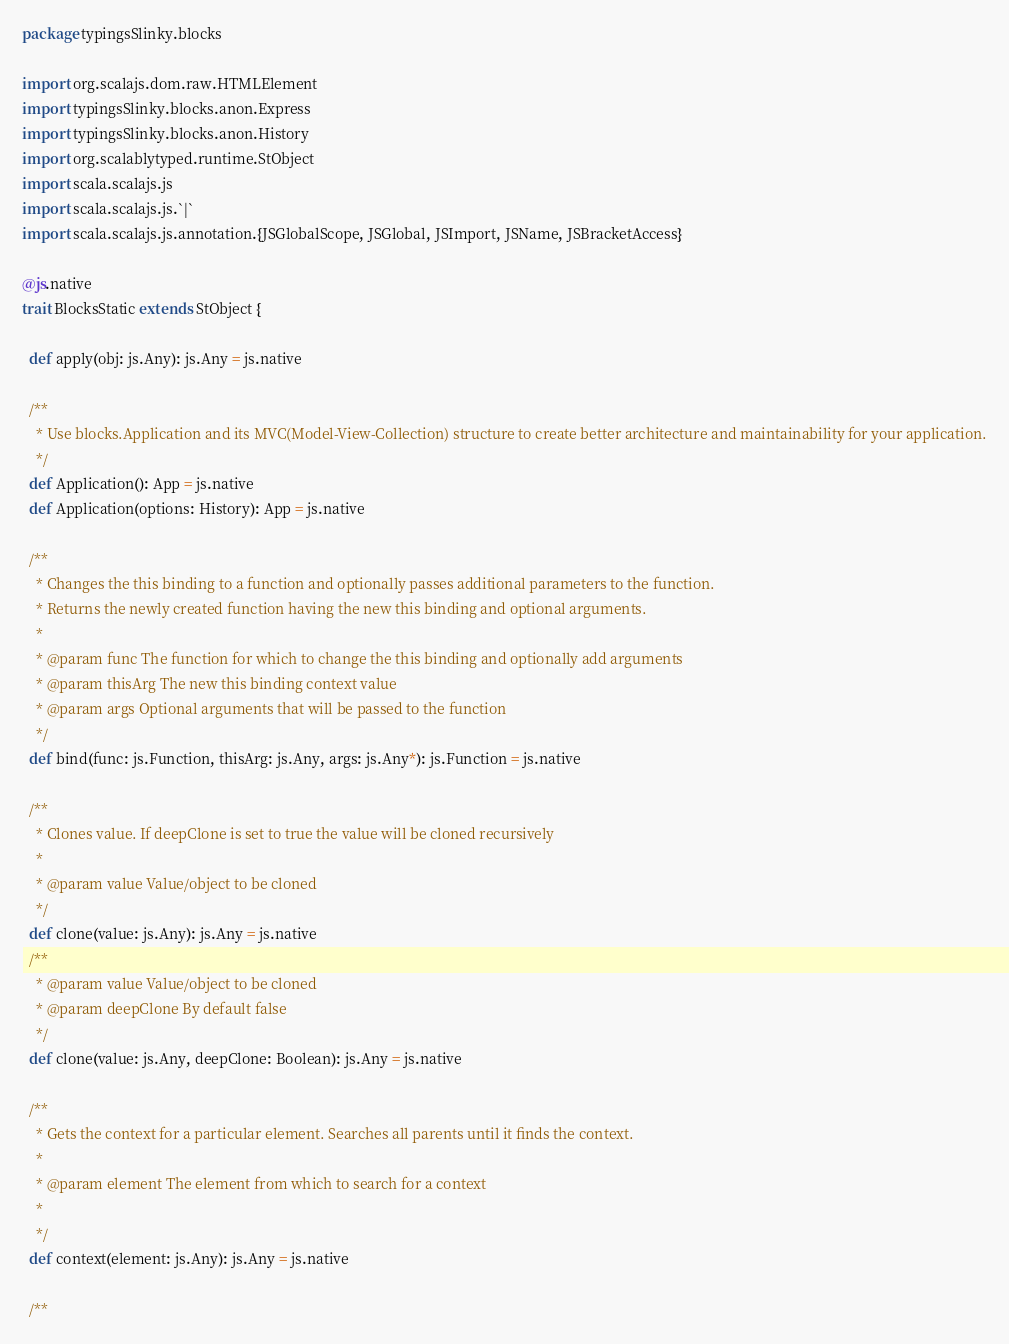<code> <loc_0><loc_0><loc_500><loc_500><_Scala_>package typingsSlinky.blocks

import org.scalajs.dom.raw.HTMLElement
import typingsSlinky.blocks.anon.Express
import typingsSlinky.blocks.anon.History
import org.scalablytyped.runtime.StObject
import scala.scalajs.js
import scala.scalajs.js.`|`
import scala.scalajs.js.annotation.{JSGlobalScope, JSGlobal, JSImport, JSName, JSBracketAccess}

@js.native
trait BlocksStatic extends StObject {
  
  def apply(obj: js.Any): js.Any = js.native
  
  /**
    * Use blocks.Application and its MVC(Model-View-Collection) structure to create better architecture and maintainability for your application.
    */
  def Application(): App = js.native
  def Application(options: History): App = js.native
  
  /**
    * Changes the this binding to a function and optionally passes additional parameters to the function.
    * Returns the newly created function having the new this binding and optional arguments.
    * 
    * @param func The function for which to change the this binding and optionally add arguments
    * @param thisArg The new this binding context value
    * @param args Optional arguments that will be passed to the function
    */
  def bind(func: js.Function, thisArg: js.Any, args: js.Any*): js.Function = js.native
  
  /**
    * Clones value. If deepClone is set to true the value will be cloned recursively
    * 
    * @param value Value/object to be cloned
    */
  def clone(value: js.Any): js.Any = js.native
  /**
    * @param value Value/object to be cloned
    * @param deepClone By default false
    */
  def clone(value: js.Any, deepClone: Boolean): js.Any = js.native
  
  /**
    * Gets the context for a particular element. Searches all parents until it finds the context.
    * 
    * @param element The element from which to search for a context
    * 
    */
  def context(element: js.Any): js.Any = js.native
  
  /**</code> 